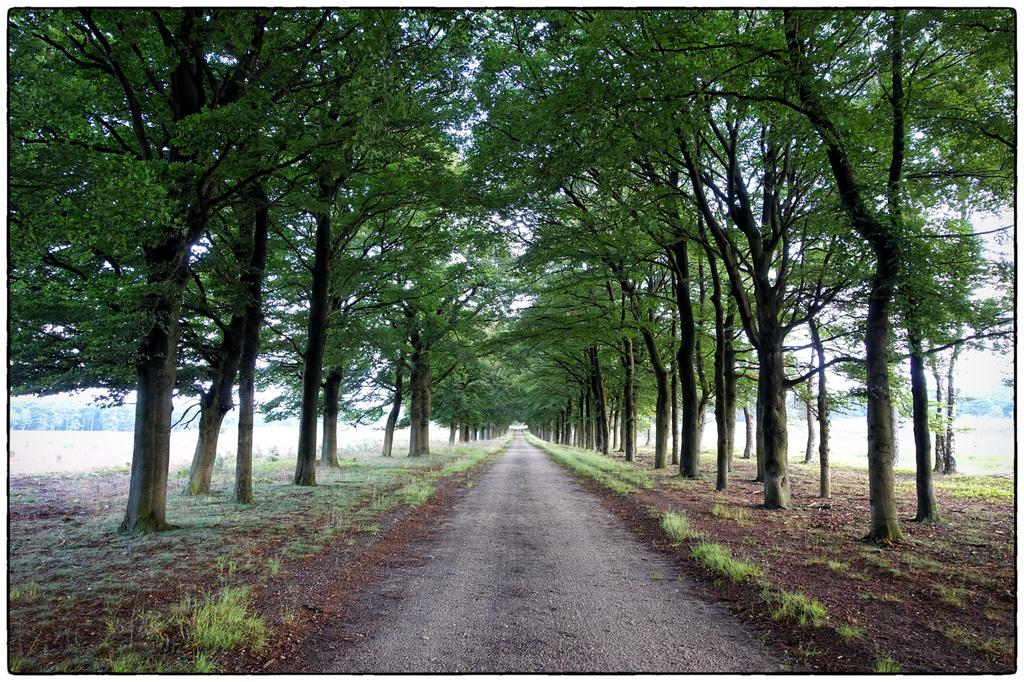What is the main feature of the image? The main feature of the image is a path or way. What can be seen on either side of the path? There are trees on either side of the path. What type of popcorn is being flown by the fowl in the image? There is no popcorn or fowl present in the image; it only features a path with trees on either side. 